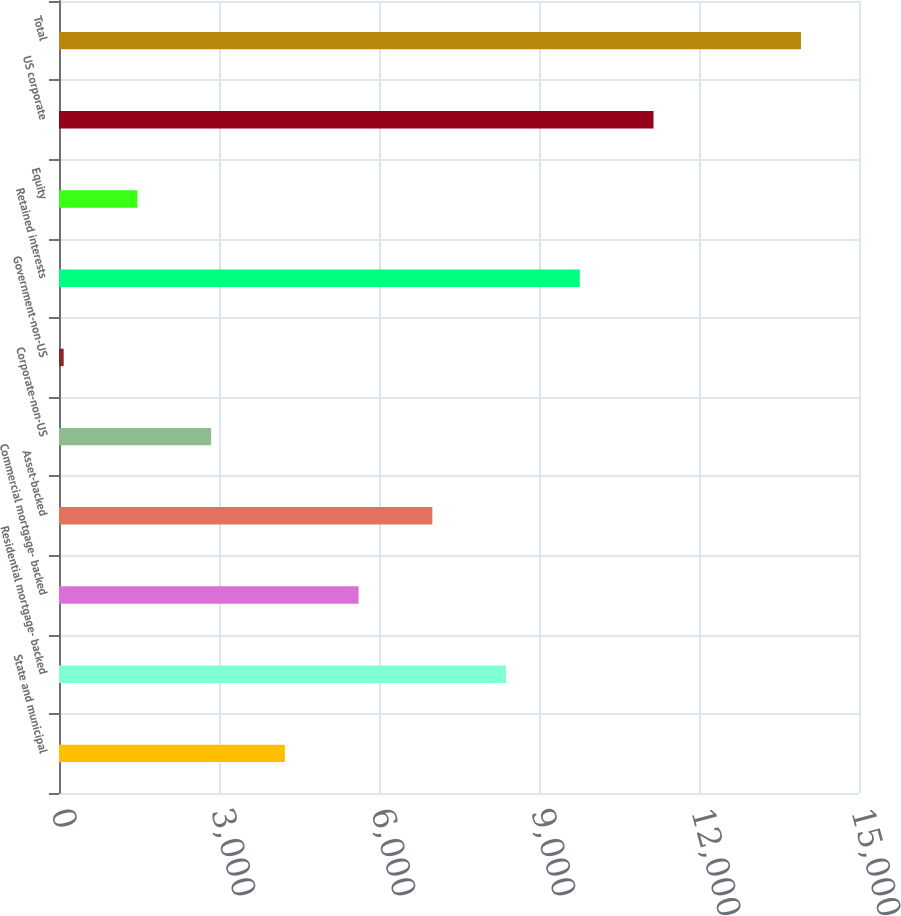<chart> <loc_0><loc_0><loc_500><loc_500><bar_chart><fcel>State and municipal<fcel>Residential mortgage- backed<fcel>Commercial mortgage- backed<fcel>Asset-backed<fcel>Corporate-non-US<fcel>Government-non-US<fcel>Retained interests<fcel>Equity<fcel>US corporate<fcel>Total<nl><fcel>4235.2<fcel>8382.4<fcel>5617.6<fcel>7000<fcel>2852.8<fcel>88<fcel>9764.8<fcel>1470.4<fcel>11147.2<fcel>13912<nl></chart> 